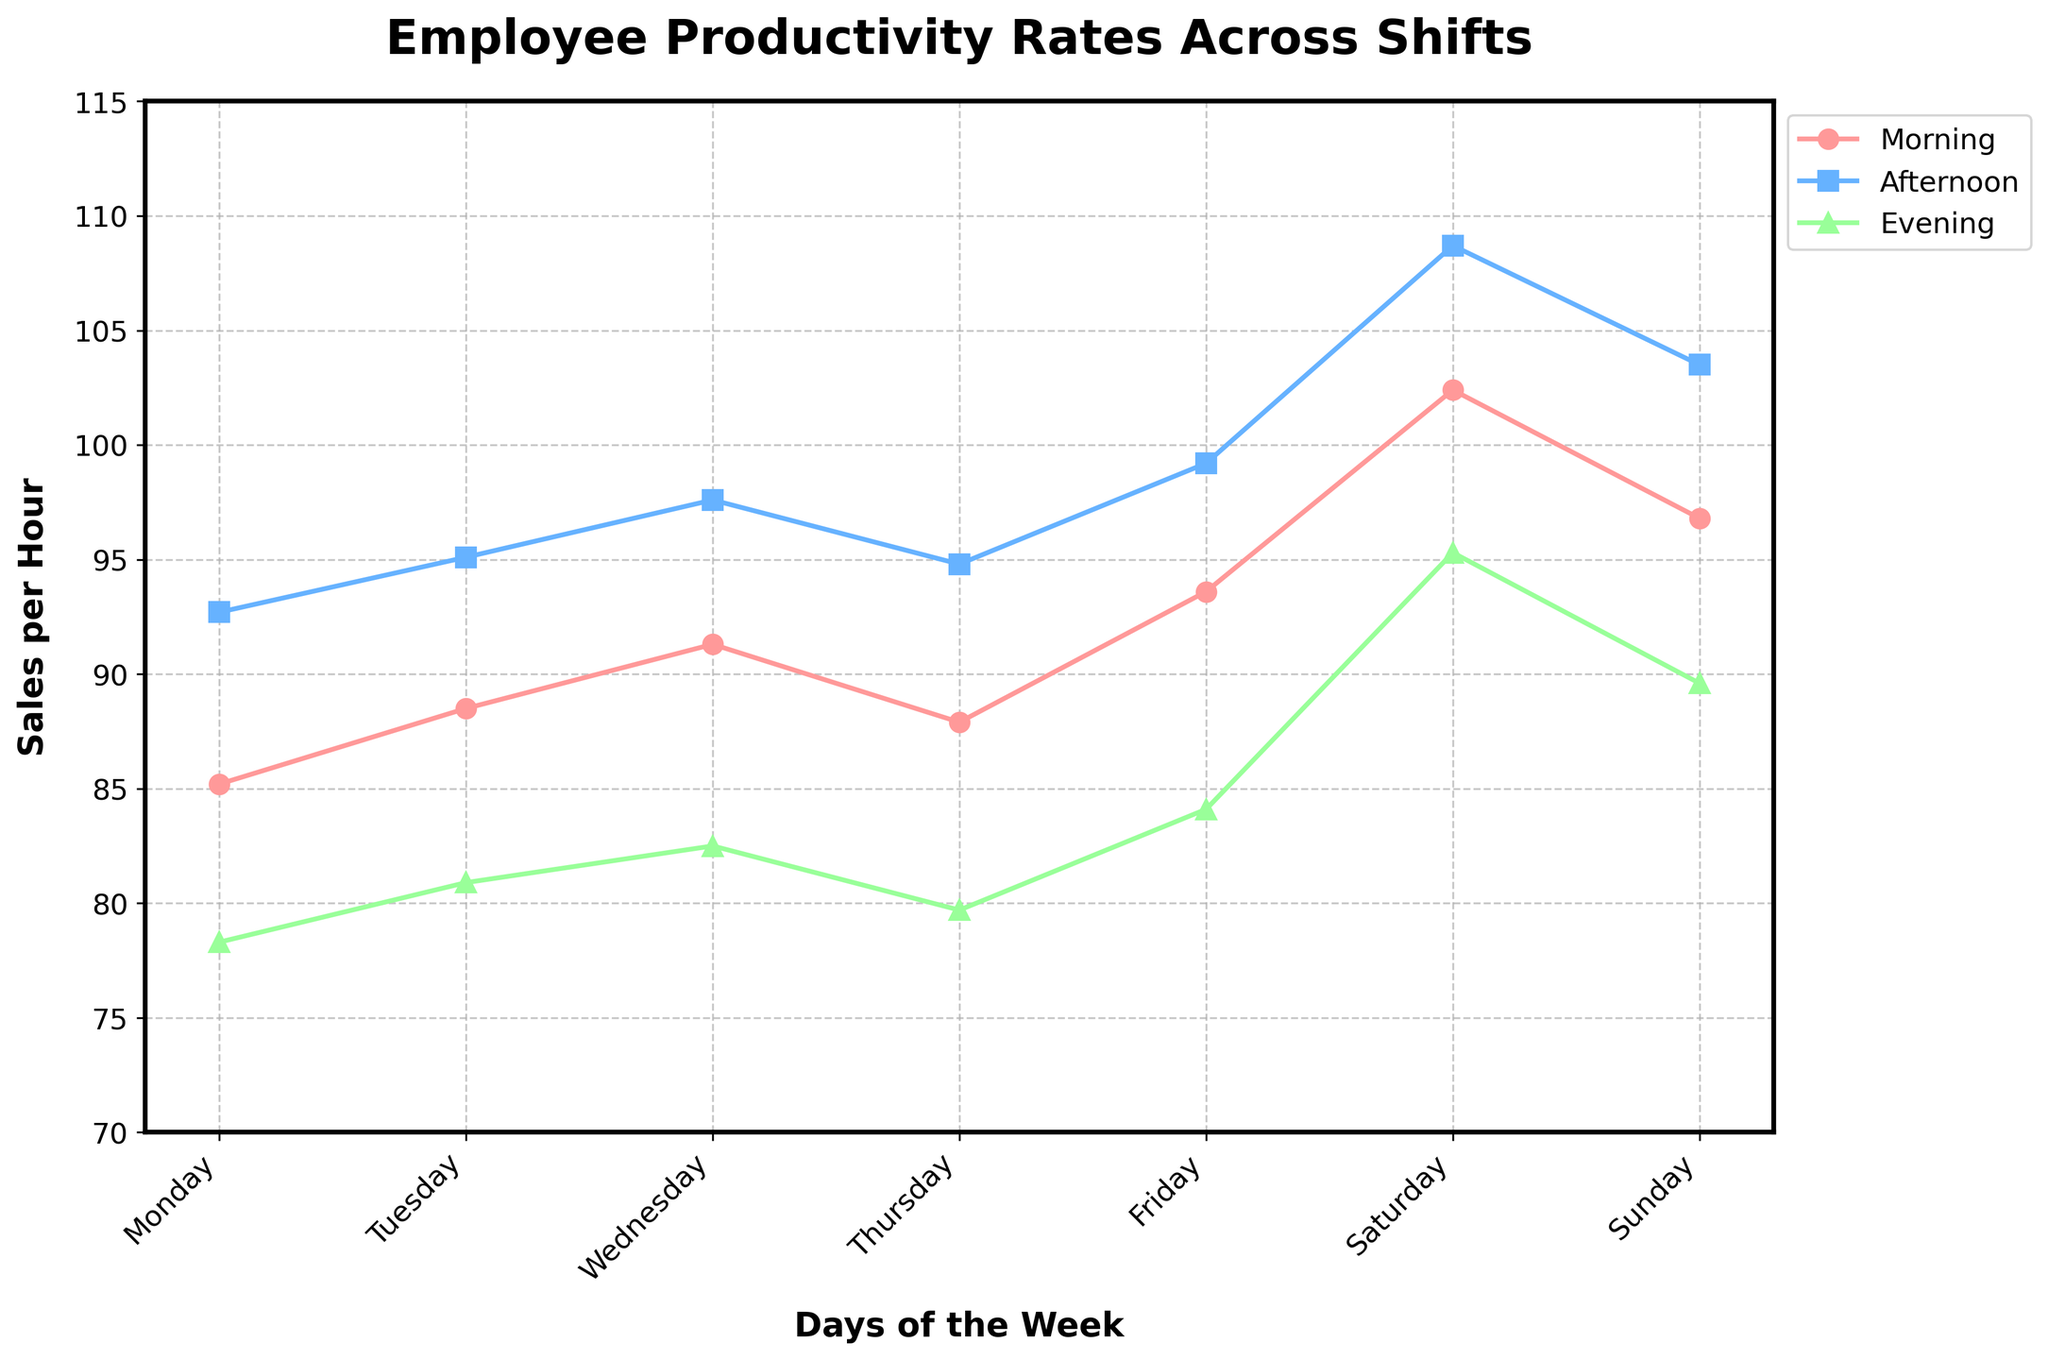what is the sales per hour rate on Friday morning compared to Wednesday afternoon? The sales per hour rate on Friday morning is 93.6, and on Wednesday afternoon it is 97.6. Comparing these, Wednesday afternoon's rate is higher.
Answer: 97.6 is higher than 93.6 Which shift has the lowest productivity rate across all days? By examining the lines, the evening shift line is consistently lower than the morning and afternoon lines across all days.
Answer: Evening What is the average sales per hour for the afternoon shift from Monday to Sunday? Summing the afternoon rates (92.7 + 95.1 + 97.6 + 94.8 + 99.2 + 108.7 + 103.5) gives 691.6, and there are 7 days. So, the average is 691.6/7.
Answer: 98.8 On which day is the difference between morning and evening productivity rates the greatest? Calculate the differences for each day and compare: (Monday: 85.2 - 78.3 = 6.9), (Tuesday: 88.5 - 80.9 = 7.6), (Wednesday: 91.3 - 82.5 = 8.8), (Thursday: 87.9 - 79.7 = 8.2), (Friday: 93.6 - 84.1 = 9.5), (Saturday: 102.4 - 95.3 = 7.1), (Sunday: 96.8 - 89.6 = 7.2). Friday has the largest difference.
Answer: Friday Is there any day when the sales per hour for all shifts are above 90? By observing the figure, only Saturday's values (102.4, 108.7, 95.3) and Sunday’s values (96.8, 103.5, 89.6) partially meet this criterion. On closer inspection, Sunday Evening shift does not exceed 90. Thus, only Saturday fits completely.
Answer: Saturday Which shift shows consistent growth in sales per hour from Monday to Friday? By observing the figure, the afternoon shift line steadily rises from Monday to Friday.
Answer: Afternoon How much higher is the sales per hour on Saturday morning compared to Thursday morning? The rates are Saturday morning 102.4 and Thursday morning 87.9. The difference is 102.4 - 87.9 = 14.5.
Answer: 14.5 Between which two consecutive days is the increase in sales per hour for the evening shift the highest? Calculate the differences for consecutive days: (Tuesday - Monday: 80.9 - 78.3 = 2.6), (Wednesday - Tuesday: 82.5 - 80.9 = 1.6), (Thursday - Wednesday: 79.7 - 82.5 = -2.8), (Friday - Thursday: 84.1 - 79.7 = 4.4), (Saturday - Friday: 95.3 - 84.1 = 11.2), (Sunday - Saturday: 89.6 - 95.3 = -5.7). The highest increase is from Friday to Saturday.
Answer: Friday to Saturday What is the range of sales per hour for the morning shift? The lowest sales per hour in the morning shift is 85.2 (Monday), and the highest is 102.4 (Saturday). The range is 102.4 - 85.2.
Answer: 17.2 